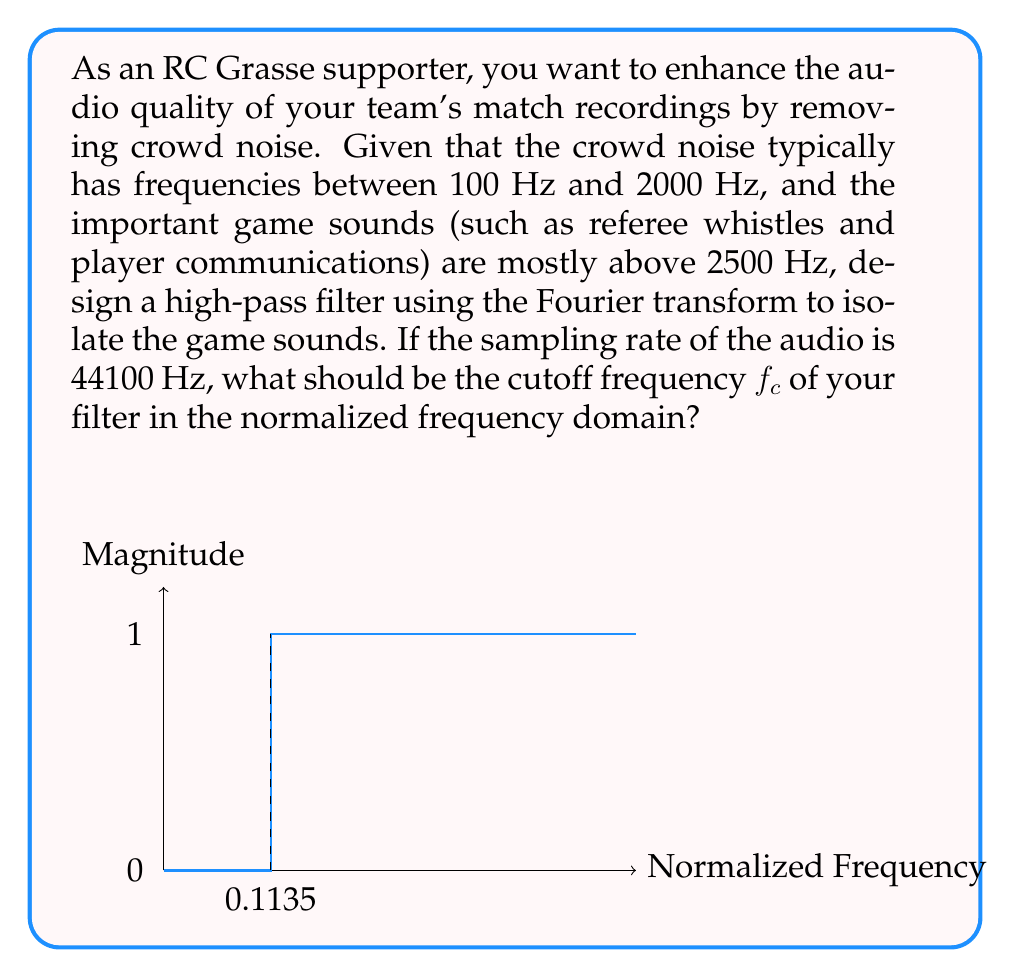Teach me how to tackle this problem. Let's approach this step-by-step:

1) First, we need to determine the cutoff frequency $f_c$ in Hz. Since we want to keep sounds above 2500 Hz, we'll set our cutoff frequency to 2500 Hz.

2) Now, we need to convert this to the normalized frequency domain. In digital signal processing, the normalized frequency is calculated as:

   $$f_{normalized} = \frac{f_{actual}}{f_{sampling}/2}$$

   Where $f_{sampling}/2$ is called the Nyquist frequency.

3) We're given that the sampling rate is 44100 Hz. So:

   $$f_{normalized} = \frac{2500}{44100/2} = \frac{2500}{22050}$$

4) Let's calculate this:

   $$f_{normalized} = 0.11337868480725624$$

5) Rounding to 4 decimal places (which is usually sufficient for audio processing):

   $$f_{normalized} \approx 0.1134$$

6) This normalized frequency represents where our high-pass filter should start allowing frequencies to pass through. In the Fourier domain, our filter would look like a step function, with magnitude 0 below this frequency and 1 above it.

7) To implement this in practice, we would take the Fourier transform of our audio signal, multiply it by our filter function, and then take the inverse Fourier transform to get our filtered audio signal.
Answer: $f_c = 0.1134$ 